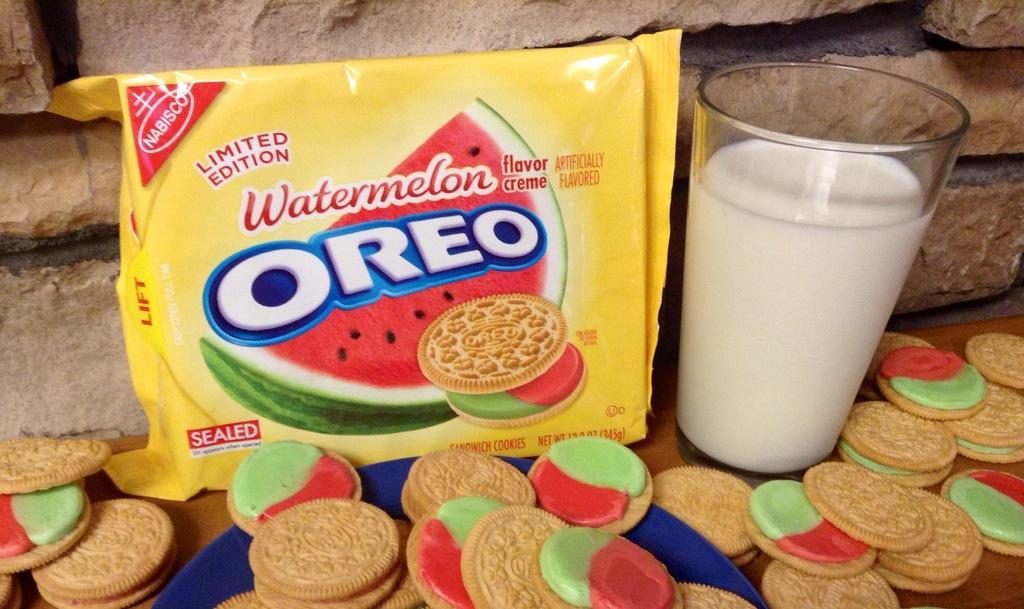Please provide a concise description of this image. In this image we can see a yellow color Oreo biscuit packet. We can also see the biscuits on the wooden surface. There is also a milk glass. In the background we can see the brick wall. 